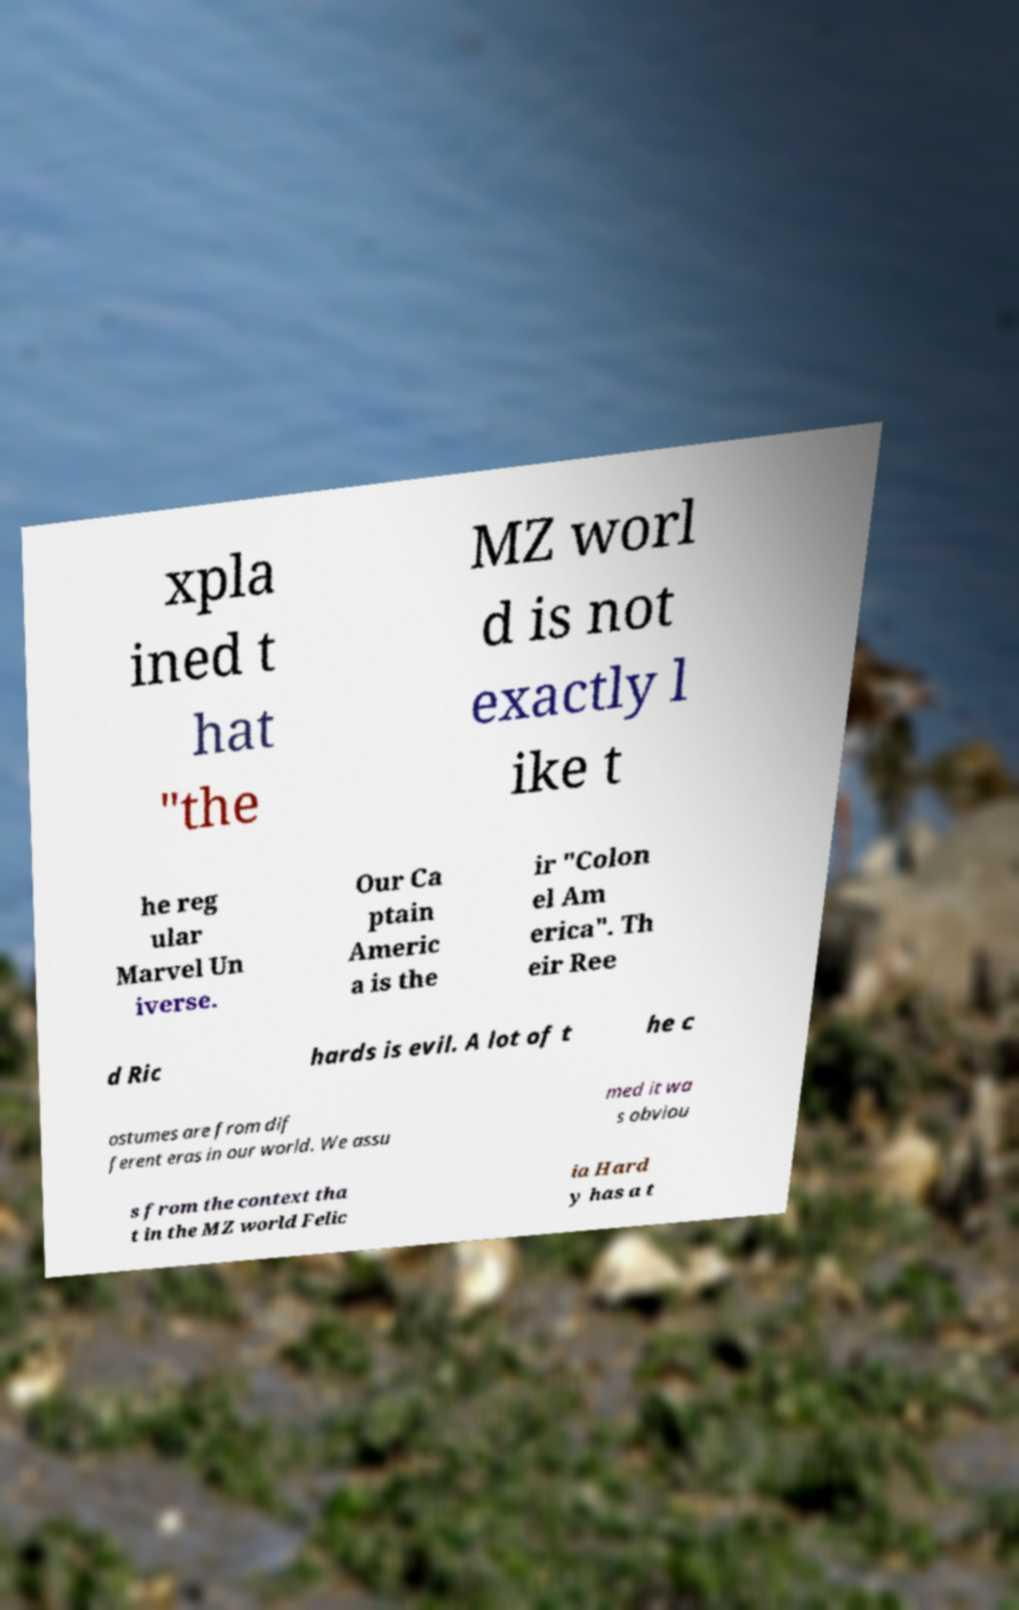What messages or text are displayed in this image? I need them in a readable, typed format. xpla ined t hat "the MZ worl d is not exactly l ike t he reg ular Marvel Un iverse. Our Ca ptain Americ a is the ir "Colon el Am erica". Th eir Ree d Ric hards is evil. A lot of t he c ostumes are from dif ferent eras in our world. We assu med it wa s obviou s from the context tha t in the MZ world Felic ia Hard y has a t 